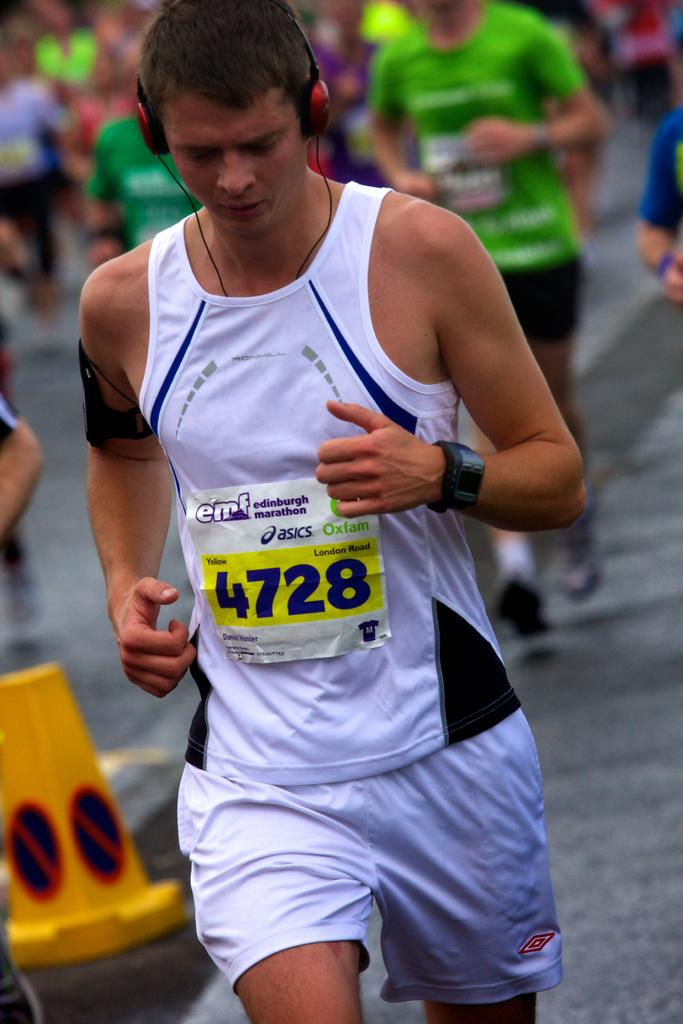<image>
Give a short and clear explanation of the subsequent image. a person with 4728 on their shirt that is running 